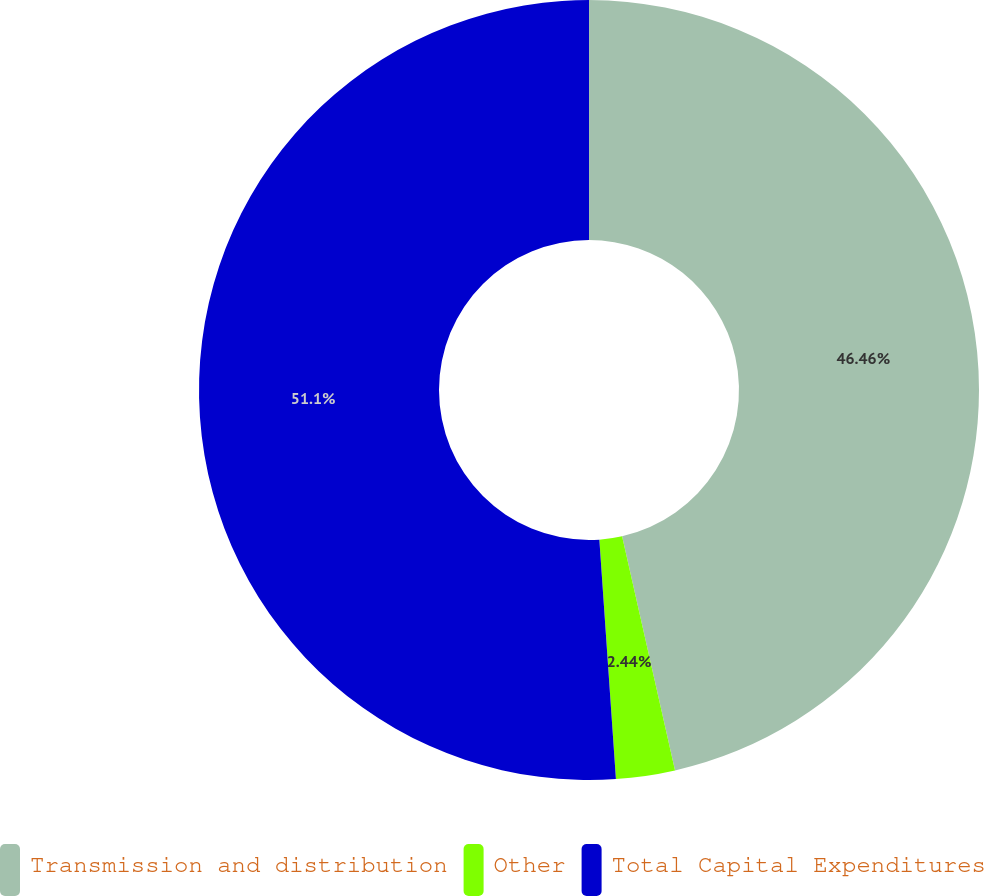Convert chart. <chart><loc_0><loc_0><loc_500><loc_500><pie_chart><fcel>Transmission and distribution<fcel>Other<fcel>Total Capital Expenditures<nl><fcel>46.46%<fcel>2.44%<fcel>51.1%<nl></chart> 